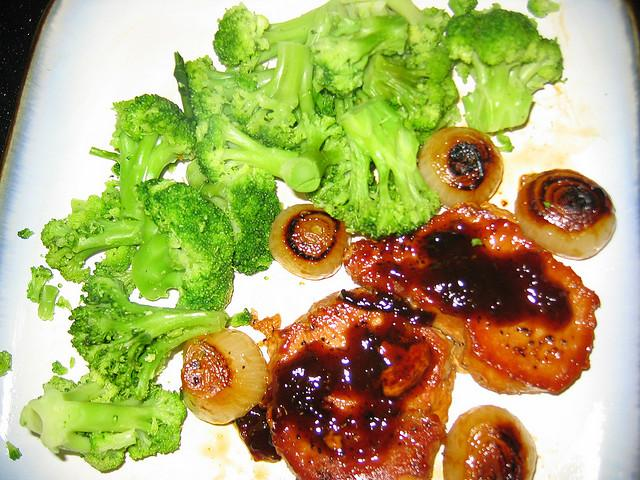What are the little round vegetables called?

Choices:
A) brussels sprouts
B) tomatoes
C) turnip
D) onions onions 